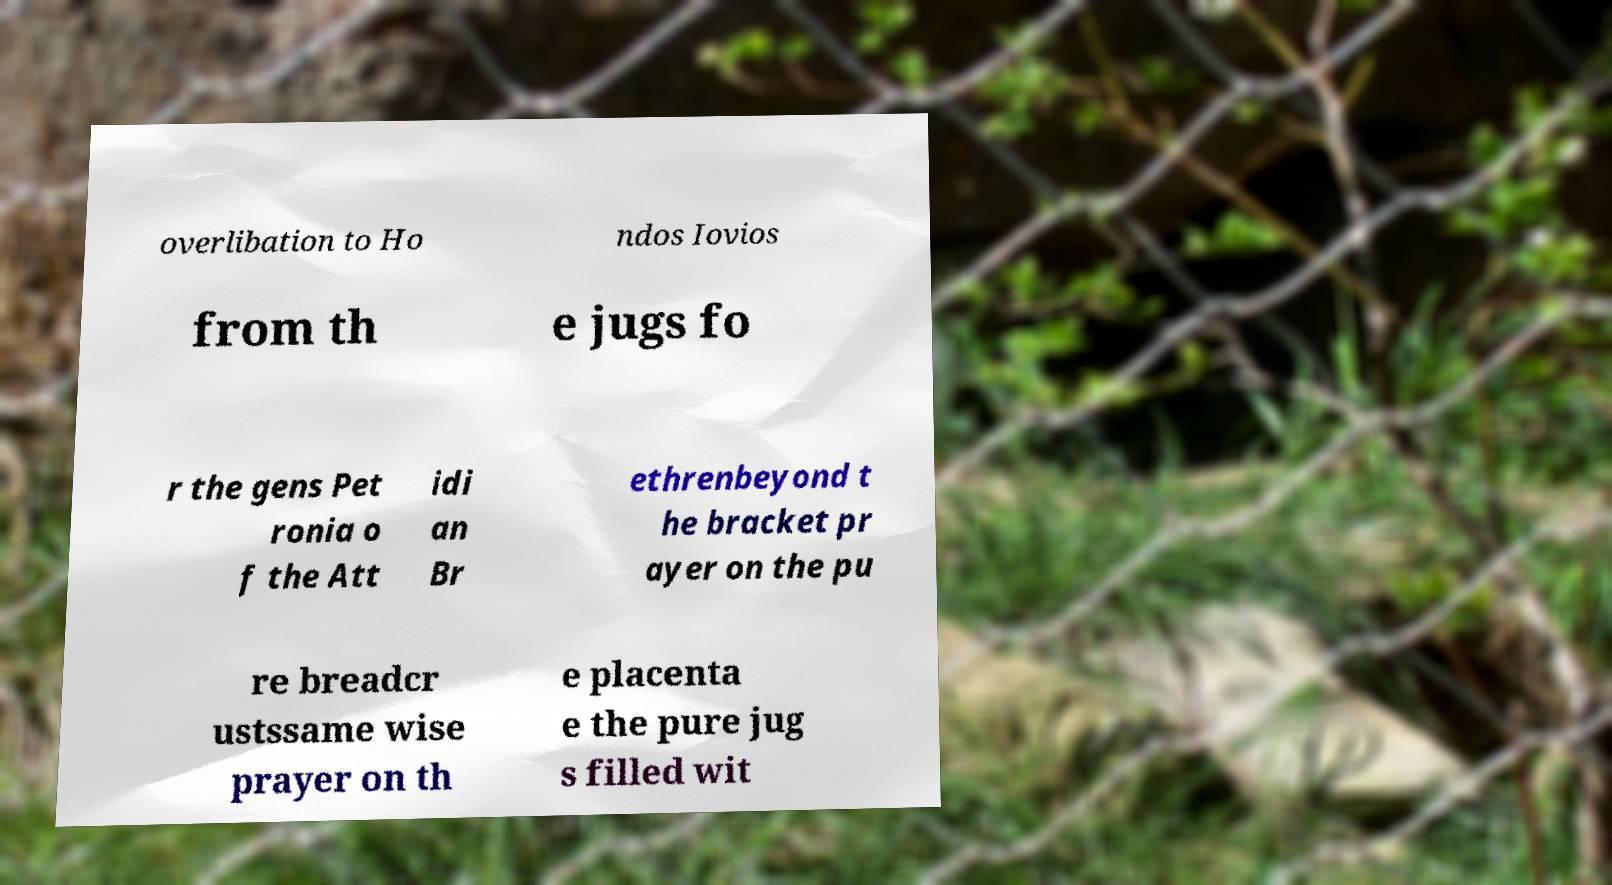There's text embedded in this image that I need extracted. Can you transcribe it verbatim? overlibation to Ho ndos Iovios from th e jugs fo r the gens Pet ronia o f the Att idi an Br ethrenbeyond t he bracket pr ayer on the pu re breadcr ustssame wise prayer on th e placenta e the pure jug s filled wit 